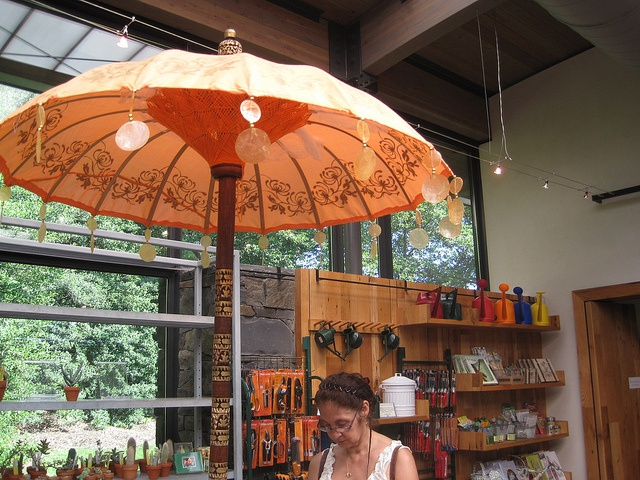Describe the objects in this image and their specific colors. I can see umbrella in darkgray, brown, beige, and salmon tones, people in darkgray, brown, maroon, black, and tan tones, potted plant in darkgray, maroon, gray, and darkgreen tones, potted plant in darkgray, gray, brown, and maroon tones, and potted plant in darkgray, gray, maroon, and black tones in this image. 